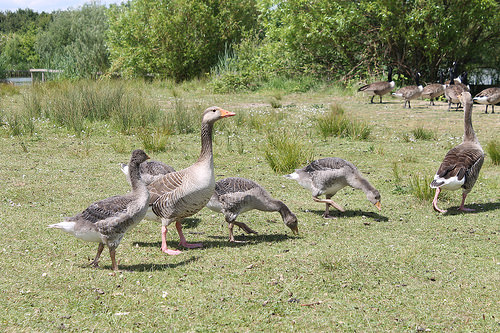<image>
Can you confirm if the grass is behind the goose? Yes. From this viewpoint, the grass is positioned behind the goose, with the goose partially or fully occluding the grass. 